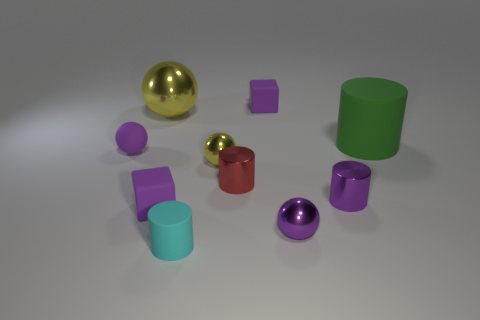Is there a large green block made of the same material as the cyan cylinder?
Your answer should be very brief. No. What is the material of the cyan object that is the same size as the red thing?
Your answer should be compact. Rubber. There is a tiny rubber object on the left side of the big yellow metallic sphere; is its color the same as the tiny block in front of the small yellow metallic sphere?
Your answer should be compact. Yes. Is there a tiny matte object that is on the right side of the sphere behind the green cylinder?
Your answer should be compact. Yes. Is the shape of the yellow object that is in front of the big green thing the same as the small rubber object in front of the purple metal ball?
Ensure brevity in your answer.  No. Does the yellow ball that is in front of the small purple matte ball have the same material as the yellow object that is left of the tiny matte cylinder?
Your response must be concise. Yes. The large object that is right of the small purple cube that is in front of the large cylinder is made of what material?
Your answer should be compact. Rubber. There is a purple thing behind the purple sphere behind the tiny purple cube to the left of the tiny yellow metal ball; what is its shape?
Offer a terse response. Cube. What material is the red thing that is the same shape as the cyan rubber object?
Offer a very short reply. Metal. What number of brown shiny objects are there?
Offer a terse response. 0. 